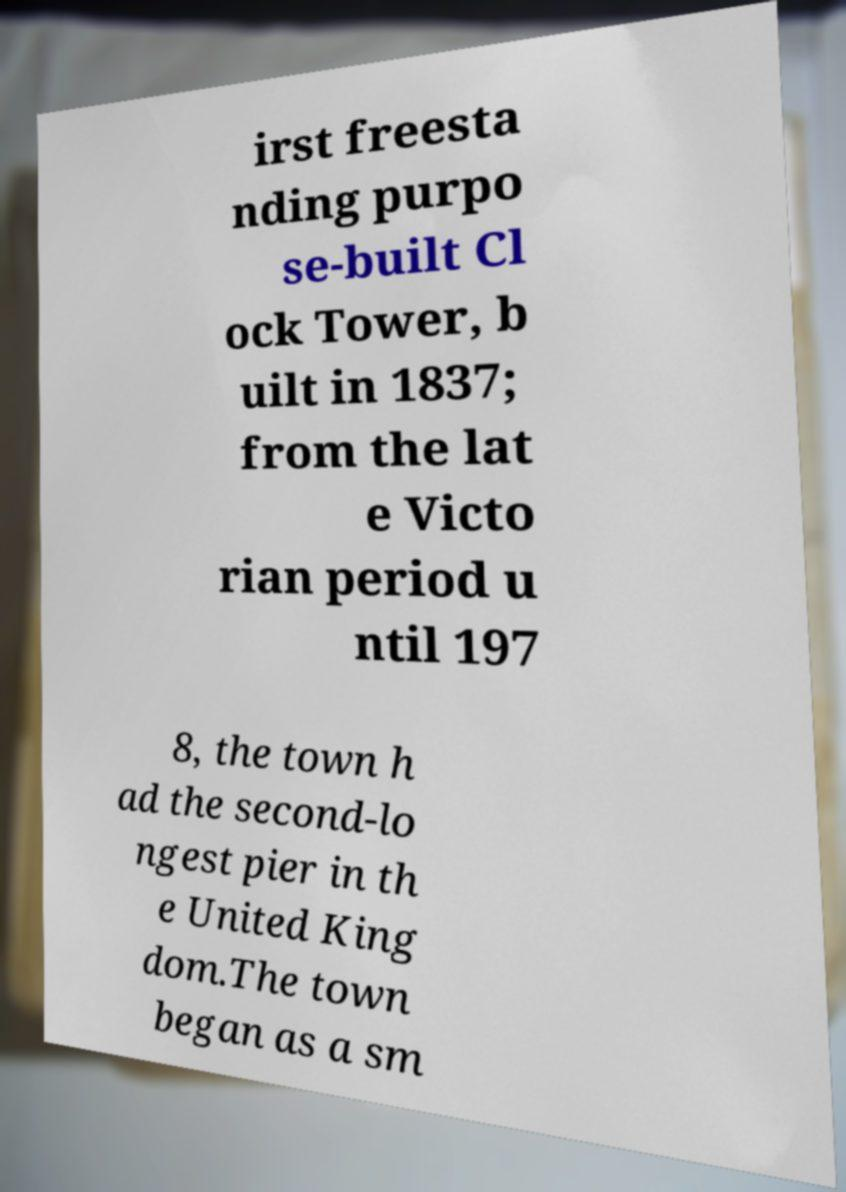What messages or text are displayed in this image? I need them in a readable, typed format. irst freesta nding purpo se-built Cl ock Tower, b uilt in 1837; from the lat e Victo rian period u ntil 197 8, the town h ad the second-lo ngest pier in th e United King dom.The town began as a sm 